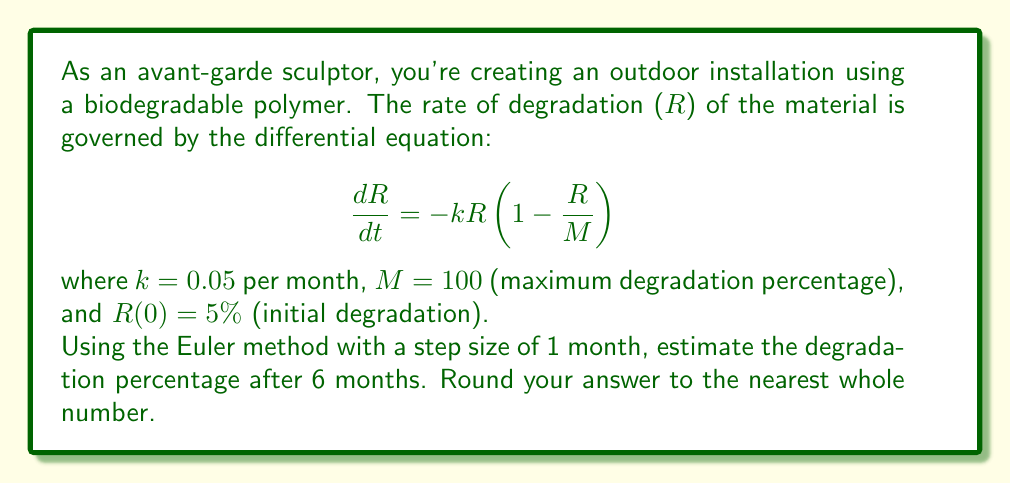Can you solve this math problem? Let's approach this step-by-step using the Euler method:

1) The Euler method is given by:
   $$R_{n+1} = R_n + h \cdot f(t_n, R_n)$$
   where $h$ is the step size (1 month), and $f(t,R) = -kR(1-\frac{R}{M})$

2) We're given:
   $k = 0.05$, $M = 100$, $R_0 = 5$, $h = 1$

3) Let's calculate for 6 steps (0 to 5 months):

   Step 0 (initial): $R_0 = 5$

   Step 1: $R_1 = 5 + 1 \cdot (-0.05 \cdot 5 \cdot (1-\frac{5}{100})) = 5 - 0.2375 = 4.7625$

   Step 2: $R_2 = 4.7625 + 1 \cdot (-0.05 \cdot 4.7625 \cdot (1-\frac{4.7625}{100})) = 4.5429$

   Step 3: $R_3 = 4.5429 + 1 \cdot (-0.05 \cdot 4.5429 \cdot (1-\frac{4.5429}{100})) = 4.3400$

   Step 4: $R_4 = 4.3400 + 1 \cdot (-0.05 \cdot 4.3400 \cdot (1-\frac{4.3400}{100})) = 4.1526$

   Step 5: $R_5 = 4.1526 + 1 \cdot (-0.05 \cdot 4.1526 \cdot (1-\frac{4.1526}{100})) = 3.9796$

   Step 6: $R_6 = 3.9796 + 1 \cdot (-0.05 \cdot 3.9796 \cdot (1-\frac{3.9796}{100})) = 3.8201$

4) The final value after 6 months is approximately 3.8201%.

5) Rounding to the nearest whole number: 4%
Answer: 4% 